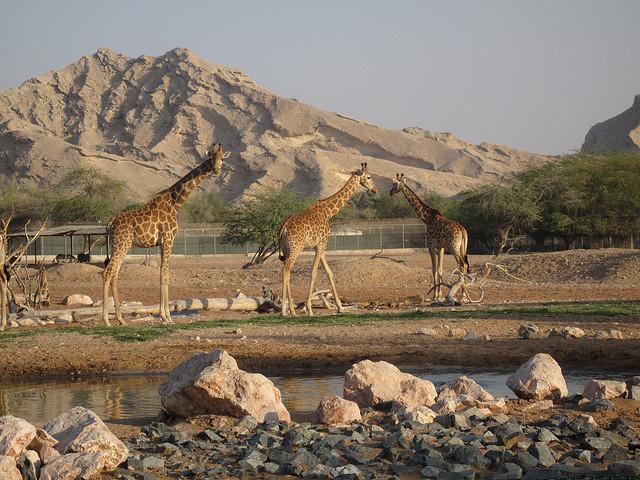How many giraffes are there?
Give a very brief answer. 3. 